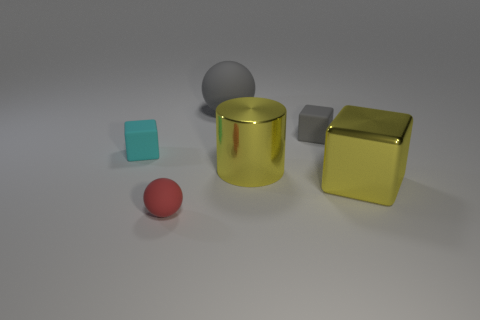Add 3 cyan rubber things. How many objects exist? 9 Subtract all spheres. How many objects are left? 4 Subtract all gray cubes. Subtract all red spheres. How many objects are left? 4 Add 1 big yellow cubes. How many big yellow cubes are left? 2 Add 6 tiny cyan matte blocks. How many tiny cyan matte blocks exist? 7 Subtract 0 green cylinders. How many objects are left? 6 